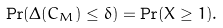Convert formula to latex. <formula><loc_0><loc_0><loc_500><loc_500>\Pr ( \Delta ( C _ { M } ) \leq \delta ) = \Pr ( X \geq 1 ) .</formula> 